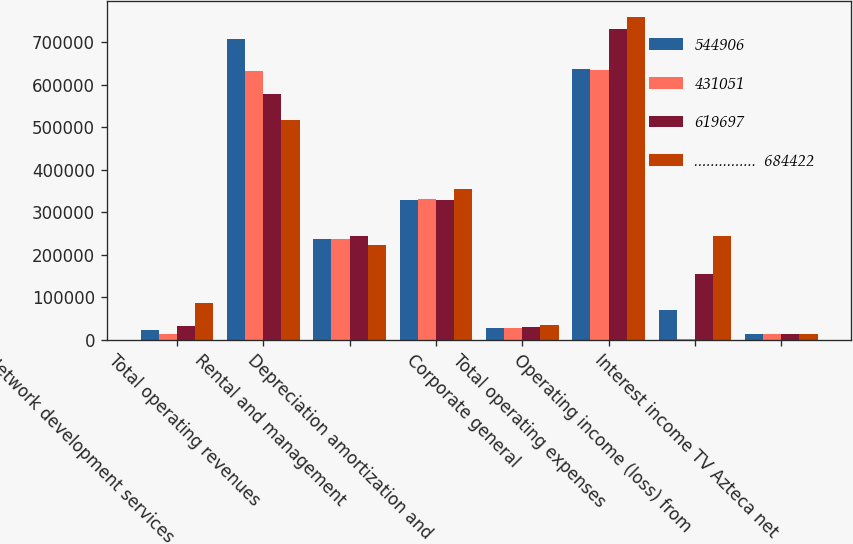<chart> <loc_0><loc_0><loc_500><loc_500><stacked_bar_chart><ecel><fcel>Network development services<fcel>Total operating revenues<fcel>Rental and management<fcel>Depreciation amortization and<fcel>Corporate general<fcel>Total operating expenses<fcel>Operating income (loss) from<fcel>Interest income TV Azteca net<nl><fcel>544906<fcel>22238<fcel>706660<fcel>237312<fcel>329449<fcel>27468<fcel>636906<fcel>69754<fcel>14316<nl><fcel>431051<fcel>12796<fcel>632493<fcel>236680<fcel>330414<fcel>26867<fcel>635110<fcel>2617<fcel>14222<nl><fcel>619697<fcel>32888<fcel>577794<fcel>242801<fcel>327665<fcel>30229<fcel>731281<fcel>153487<fcel>13938<nl><fcel>...............  684422<fcel>85063<fcel>516114<fcel>221759<fcel>354298<fcel>34310<fcel>759234<fcel>243120<fcel>14377<nl></chart> 